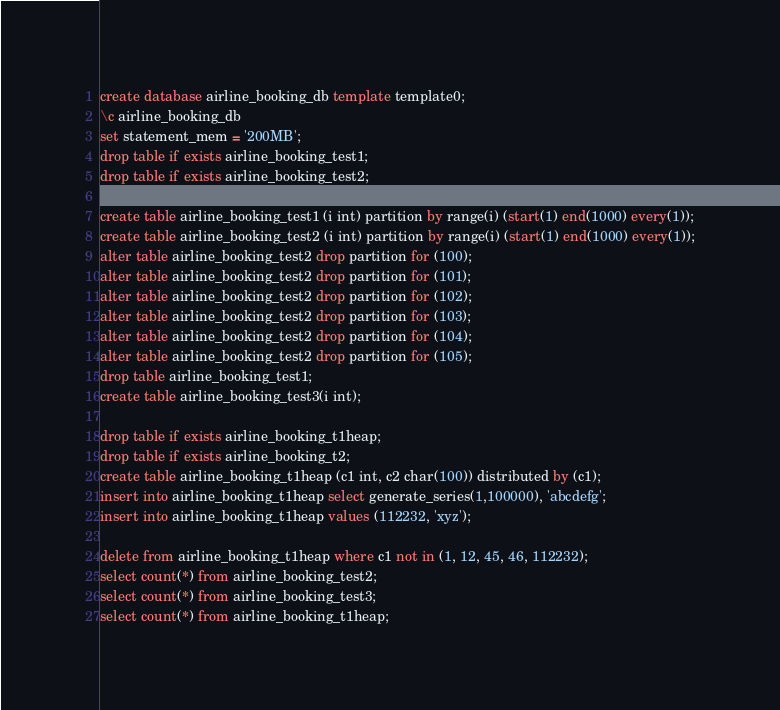<code> <loc_0><loc_0><loc_500><loc_500><_SQL_>create database airline_booking_db template template0;
\c airline_booking_db
set statement_mem = '200MB';
drop table if exists airline_booking_test1;
drop table if exists airline_booking_test2;

create table airline_booking_test1 (i int) partition by range(i) (start(1) end(1000) every(1));
create table airline_booking_test2 (i int) partition by range(i) (start(1) end(1000) every(1));
alter table airline_booking_test2 drop partition for (100);
alter table airline_booking_test2 drop partition for (101);
alter table airline_booking_test2 drop partition for (102);
alter table airline_booking_test2 drop partition for (103);
alter table airline_booking_test2 drop partition for (104);
alter table airline_booking_test2 drop partition for (105);
drop table airline_booking_test1;
create table airline_booking_test3(i int);

drop table if exists airline_booking_t1heap;
drop table if exists airline_booking_t2;
create table airline_booking_t1heap (c1 int, c2 char(100)) distributed by (c1);
insert into airline_booking_t1heap select generate_series(1,100000), 'abcdefg';
insert into airline_booking_t1heap values (112232, 'xyz');

delete from airline_booking_t1heap where c1 not in (1, 12, 45, 46, 112232);
select count(*) from airline_booking_test2;
select count(*) from airline_booking_test3;
select count(*) from airline_booking_t1heap;

</code> 